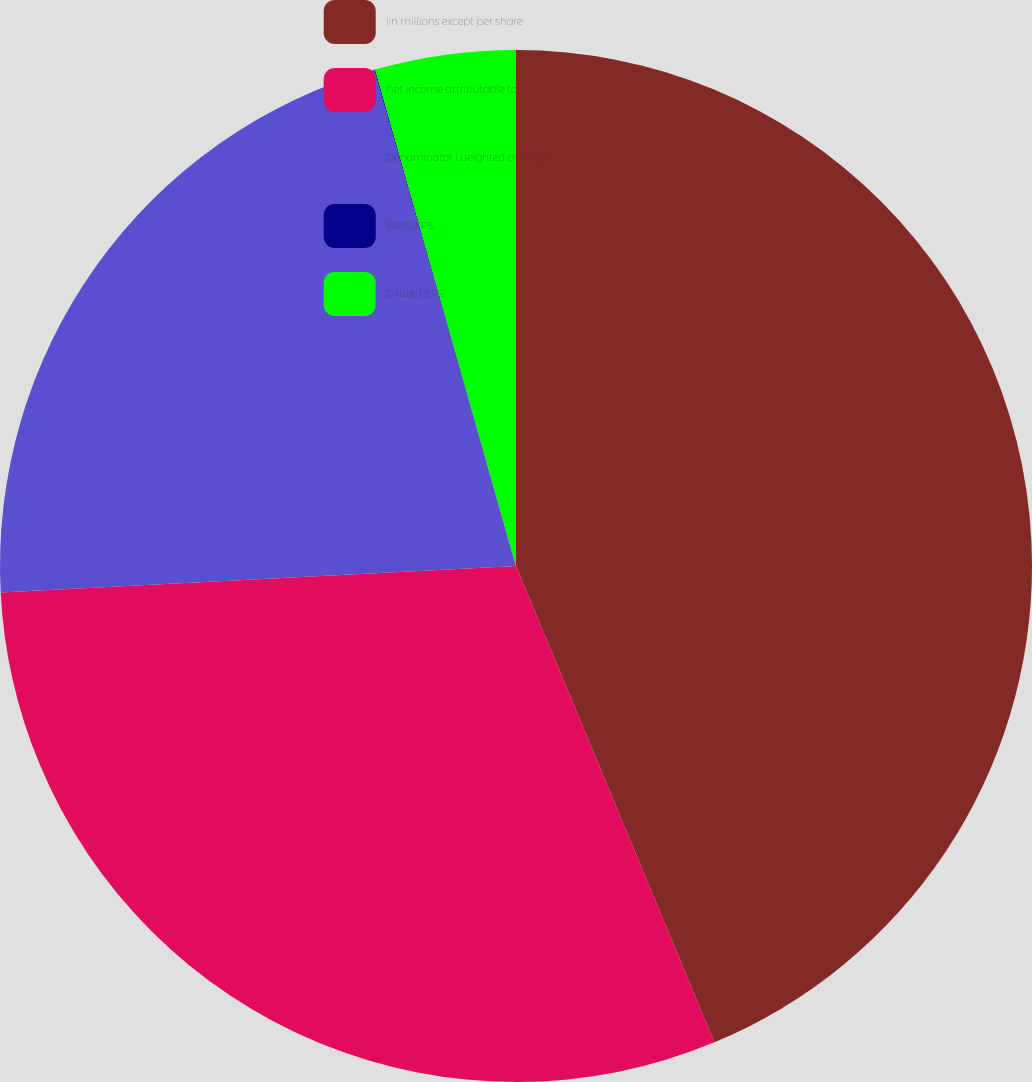Convert chart. <chart><loc_0><loc_0><loc_500><loc_500><pie_chart><fcel>(in millions except per share<fcel>Net income attributable to<fcel>Denominator Weighted average<fcel>Basic EPS<fcel>Diluted EPS<nl><fcel>43.72%<fcel>30.46%<fcel>21.39%<fcel>0.03%<fcel>4.4%<nl></chart> 